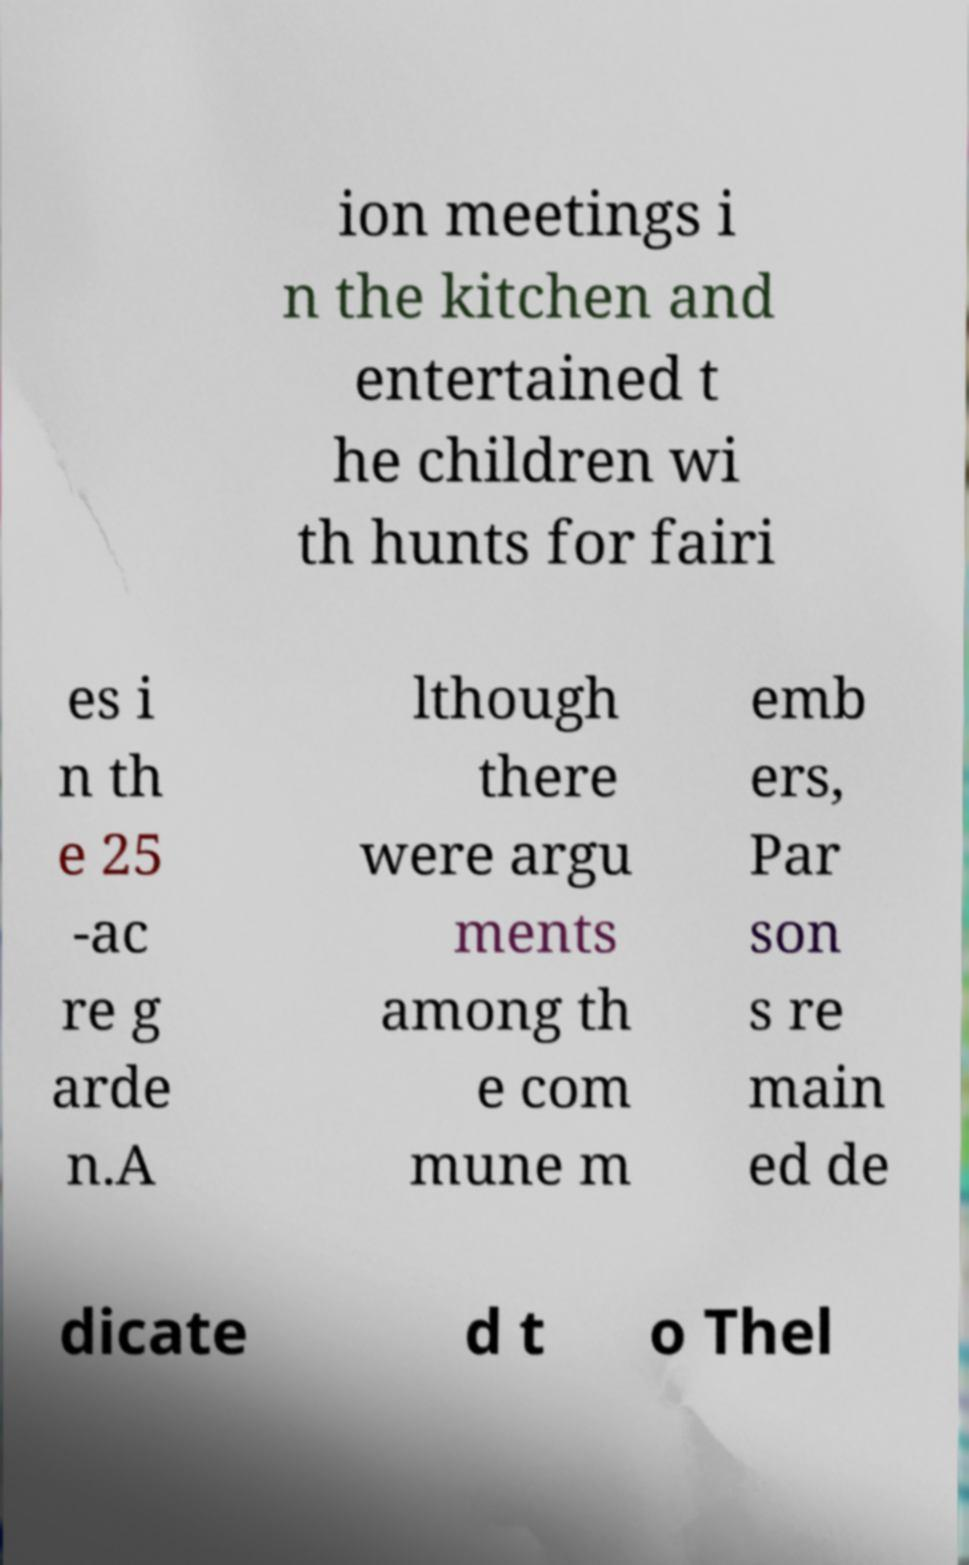Could you extract and type out the text from this image? ion meetings i n the kitchen and entertained t he children wi th hunts for fairi es i n th e 25 -ac re g arde n.A lthough there were argu ments among th e com mune m emb ers, Par son s re main ed de dicate d t o Thel 